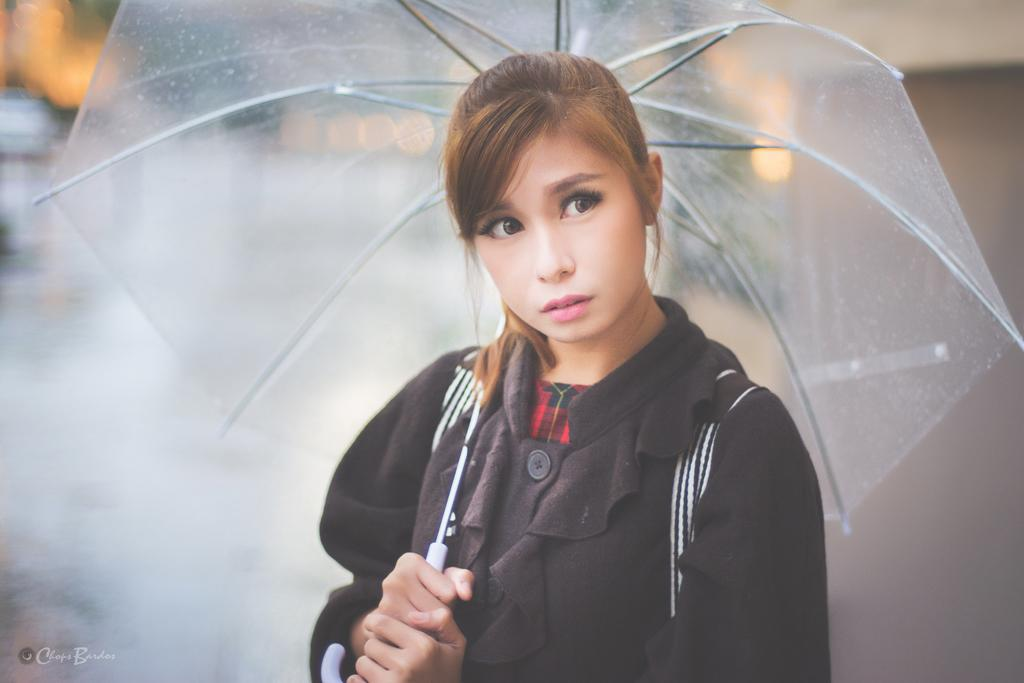Who is present in the image? There is a woman in the picture. What is the woman holding in the image? The woman is holding an umbrella. Can you describe the background of the image? The background of the image is blurred. What type of plate is on the table in the image? There is no table or plate present in the image; it features a woman holding an umbrella with a blurred background. 